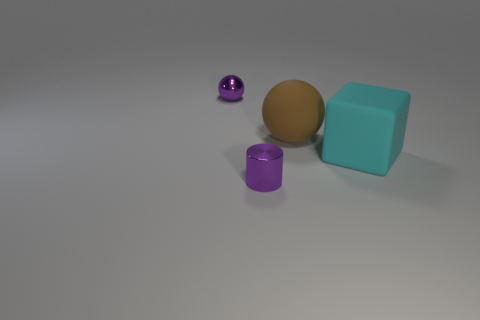Add 2 cyan cubes. How many objects exist? 6 Subtract all cylinders. How many objects are left? 3 Add 1 small blue rubber cylinders. How many small blue rubber cylinders exist? 1 Subtract 1 brown spheres. How many objects are left? 3 Subtract all tiny brown matte spheres. Subtract all purple metallic things. How many objects are left? 2 Add 1 big cubes. How many big cubes are left? 2 